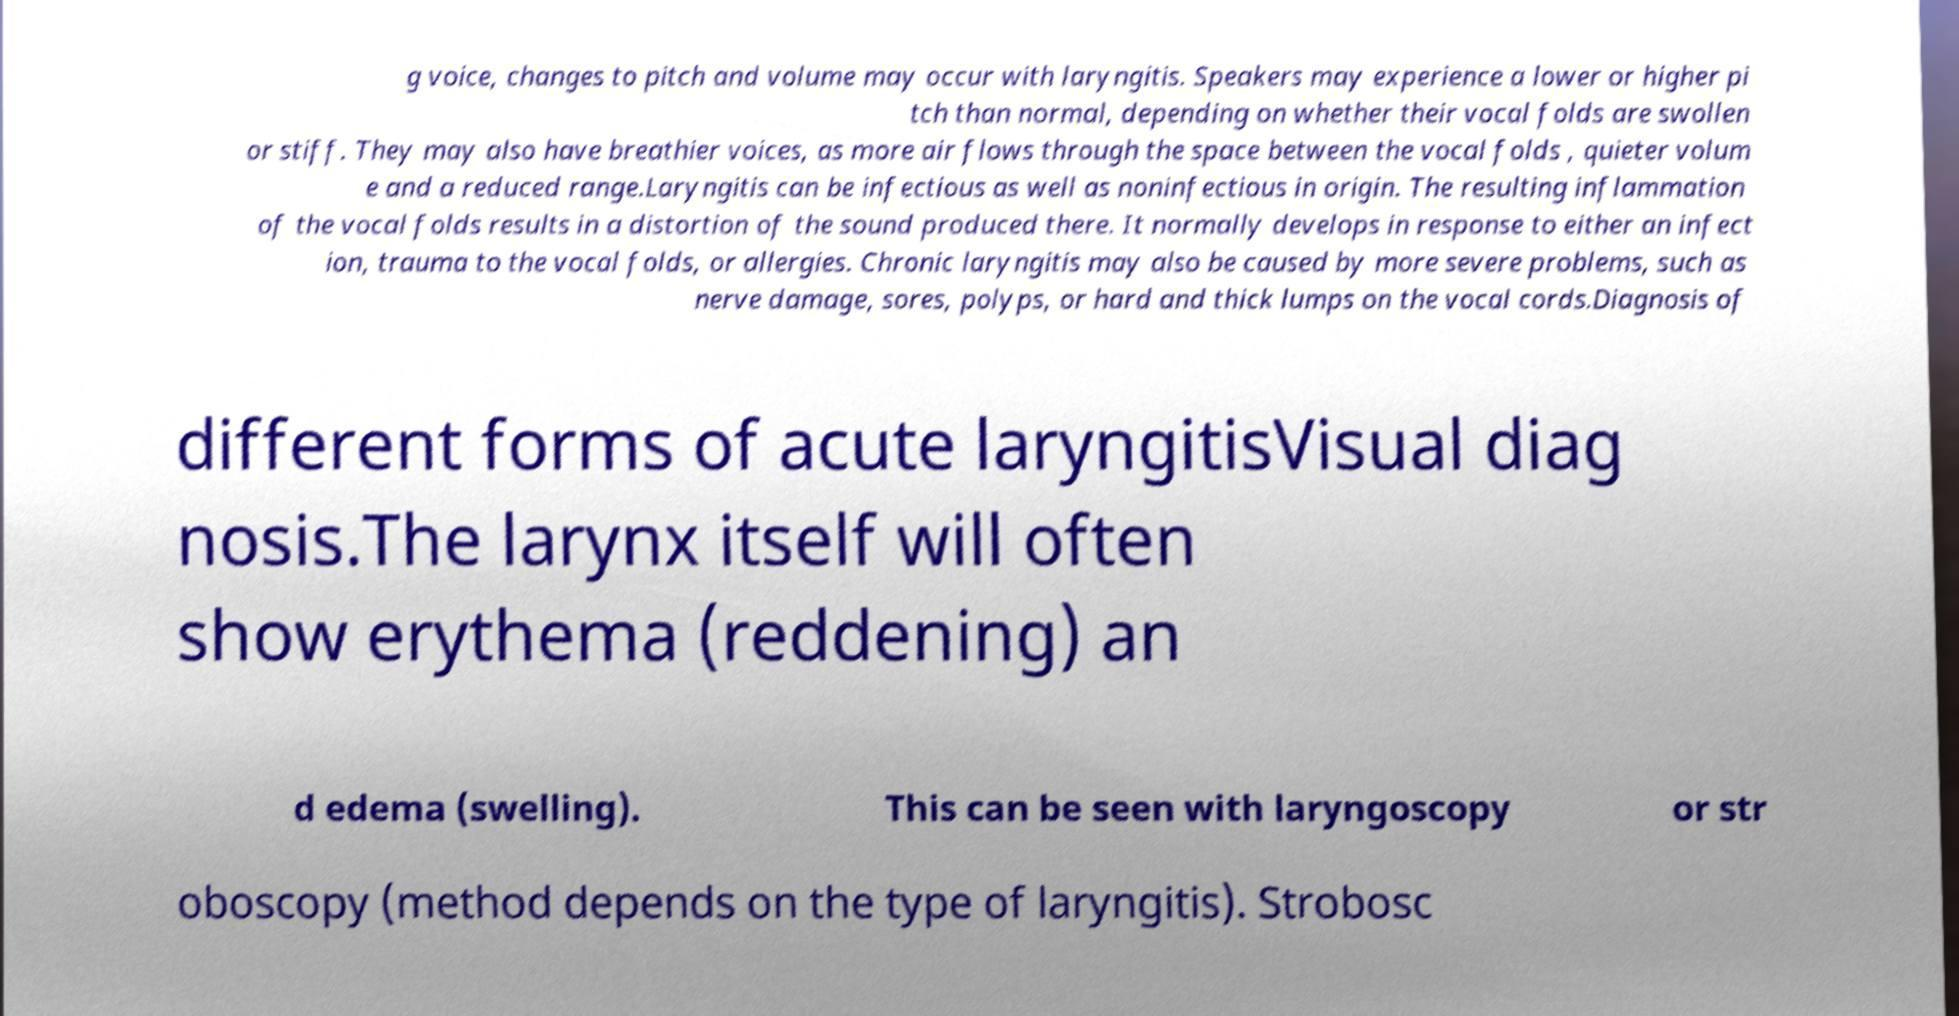There's text embedded in this image that I need extracted. Can you transcribe it verbatim? g voice, changes to pitch and volume may occur with laryngitis. Speakers may experience a lower or higher pi tch than normal, depending on whether their vocal folds are swollen or stiff. They may also have breathier voices, as more air flows through the space between the vocal folds , quieter volum e and a reduced range.Laryngitis can be infectious as well as noninfectious in origin. The resulting inflammation of the vocal folds results in a distortion of the sound produced there. It normally develops in response to either an infect ion, trauma to the vocal folds, or allergies. Chronic laryngitis may also be caused by more severe problems, such as nerve damage, sores, polyps, or hard and thick lumps on the vocal cords.Diagnosis of different forms of acute laryngitisVisual diag nosis.The larynx itself will often show erythema (reddening) an d edema (swelling). This can be seen with laryngoscopy or str oboscopy (method depends on the type of laryngitis). Strobosc 